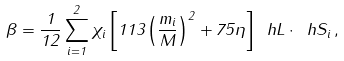<formula> <loc_0><loc_0><loc_500><loc_500>\beta = \frac { 1 } { 1 2 } \sum _ { i = 1 } ^ { 2 } \chi _ { i } \left [ 1 1 3 \left ( \frac { m _ { i } } { M } \right ) ^ { 2 } + 7 5 \eta \right ] \ h L \cdot \ h S _ { i } \, ,</formula> 